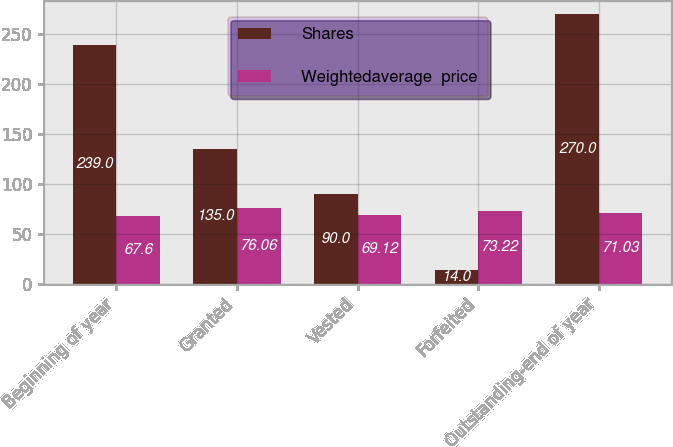Convert chart. <chart><loc_0><loc_0><loc_500><loc_500><stacked_bar_chart><ecel><fcel>Beginning of year<fcel>Granted<fcel>Vested<fcel>Forfeited<fcel>Outstanding-end of year<nl><fcel>Shares<fcel>239<fcel>135<fcel>90<fcel>14<fcel>270<nl><fcel>Weightedaverage  price<fcel>67.6<fcel>76.06<fcel>69.12<fcel>73.22<fcel>71.03<nl></chart> 